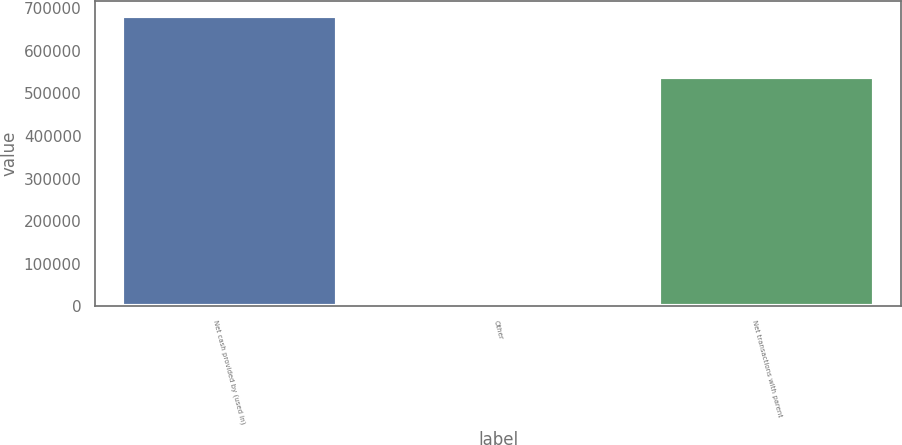Convert chart. <chart><loc_0><loc_0><loc_500><loc_500><bar_chart><fcel>Net cash provided by (used in)<fcel>Other<fcel>Net transactions with parent<nl><fcel>682746<fcel>4433<fcel>537505<nl></chart> 